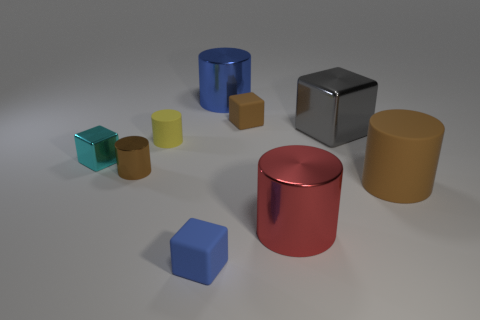What number of yellow matte things are there?
Your answer should be compact. 1. There is a blue object that is made of the same material as the gray object; what shape is it?
Your answer should be very brief. Cylinder. There is a metallic cylinder left of the tiny matte cylinder to the left of the blue cube; what size is it?
Offer a very short reply. Small. How many things are either large shiny cylinders that are on the left side of the red shiny cylinder or blue cylinders that are to the right of the tiny rubber cylinder?
Provide a succinct answer. 1. Are there fewer large cylinders than large yellow metal cylinders?
Keep it short and to the point. No. What number of things are large brown cylinders or large gray cylinders?
Provide a short and direct response. 1. Is the shape of the small cyan metallic thing the same as the large red object?
Ensure brevity in your answer.  No. Is there any other thing that has the same material as the large block?
Keep it short and to the point. Yes. Does the blue thing on the right side of the blue matte cube have the same size as the brown rubber thing that is in front of the large block?
Your response must be concise. Yes. The big object that is both to the right of the red thing and behind the cyan metallic block is made of what material?
Ensure brevity in your answer.  Metal. 